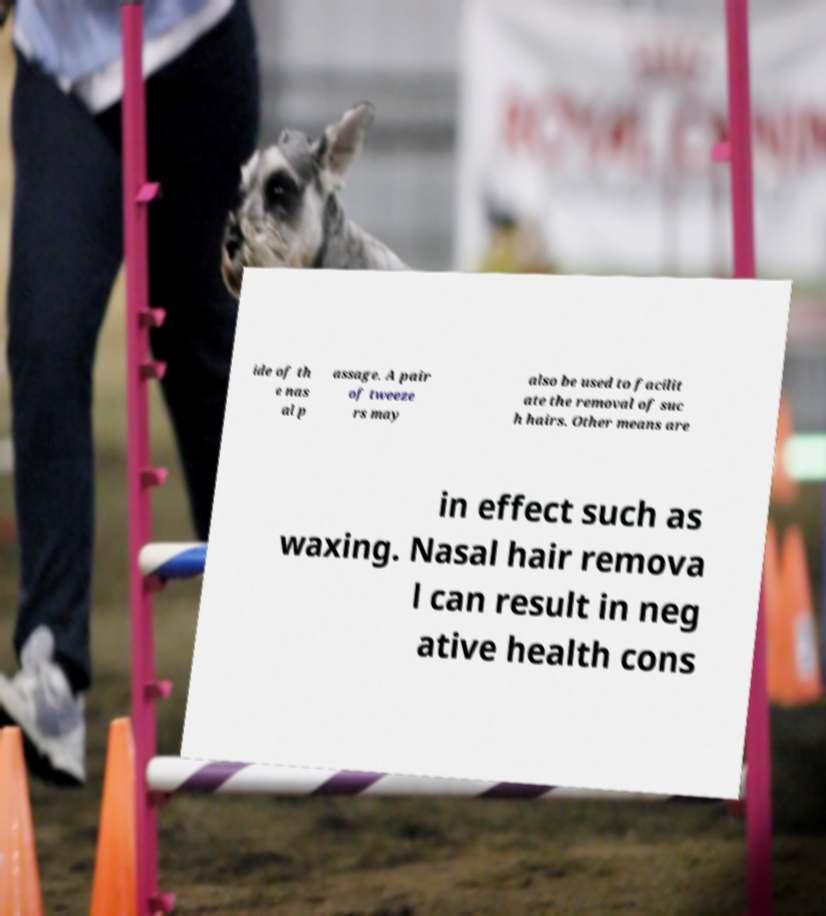Please read and relay the text visible in this image. What does it say? ide of th e nas al p assage. A pair of tweeze rs may also be used to facilit ate the removal of suc h hairs. Other means are in effect such as waxing. Nasal hair remova l can result in neg ative health cons 